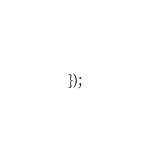<code> <loc_0><loc_0><loc_500><loc_500><_JavaScript_>});
</code> 